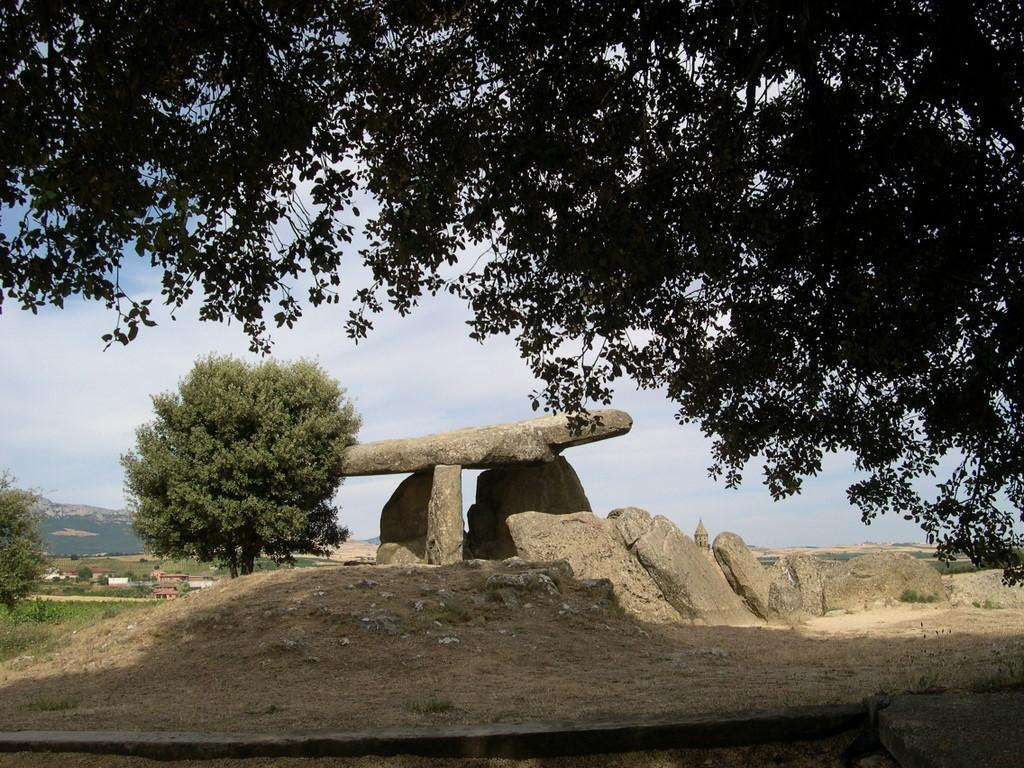What can be found at the bottom of the image? At the bottom of the image, there are stones, trees, grass, hills, and land. What is present at the top of the image? At the top of the image, there are trees and sky visible. What can be seen in the sky at the top of the image? In the sky at the top of the image, there are clouds visible. Where are the children playing with the tray in the image? There are no children or tray present in the image. What does the mom say to the children in the image? There are no children or mom present in the image, so it is not possible to answer this question. 